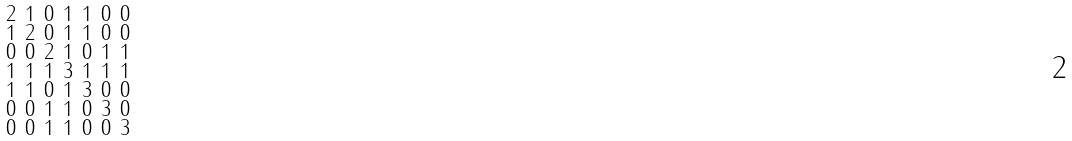<formula> <loc_0><loc_0><loc_500><loc_500>\begin{smallmatrix} 2 & 1 & 0 & 1 & 1 & 0 & 0 \\ 1 & 2 & 0 & 1 & 1 & 0 & 0 \\ 0 & 0 & 2 & 1 & 0 & 1 & 1 \\ 1 & 1 & 1 & 3 & 1 & 1 & 1 \\ 1 & 1 & 0 & 1 & 3 & 0 & 0 \\ 0 & 0 & 1 & 1 & 0 & 3 & 0 \\ 0 & 0 & 1 & 1 & 0 & 0 & 3 \end{smallmatrix}</formula> 